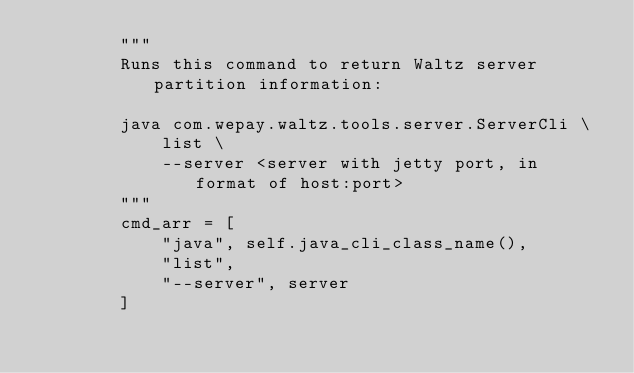Convert code to text. <code><loc_0><loc_0><loc_500><loc_500><_Python_>        """
        Runs this command to return Waltz server partition information:

        java com.wepay.waltz.tools.server.ServerCli \
            list \
            --server <server with jetty port, in format of host:port>
        """
        cmd_arr = [
            "java", self.java_cli_class_name(),
            "list",
            "--server", server
        ]
</code> 